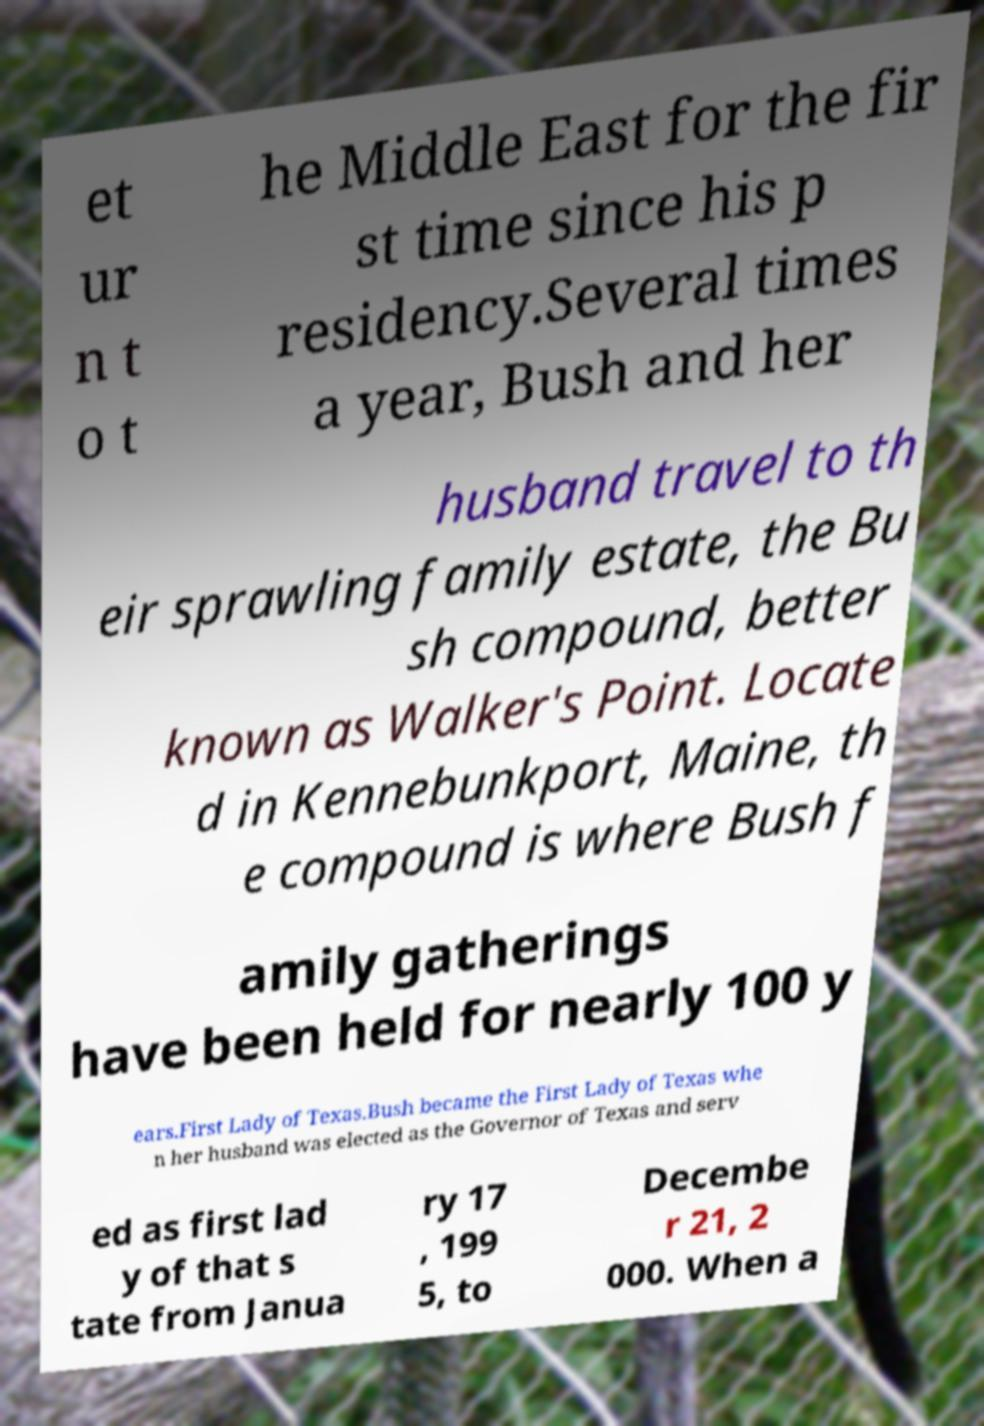I need the written content from this picture converted into text. Can you do that? et ur n t o t he Middle East for the fir st time since his p residency.Several times a year, Bush and her husband travel to th eir sprawling family estate, the Bu sh compound, better known as Walker's Point. Locate d in Kennebunkport, Maine, th e compound is where Bush f amily gatherings have been held for nearly 100 y ears.First Lady of Texas.Bush became the First Lady of Texas whe n her husband was elected as the Governor of Texas and serv ed as first lad y of that s tate from Janua ry 17 , 199 5, to Decembe r 21, 2 000. When a 